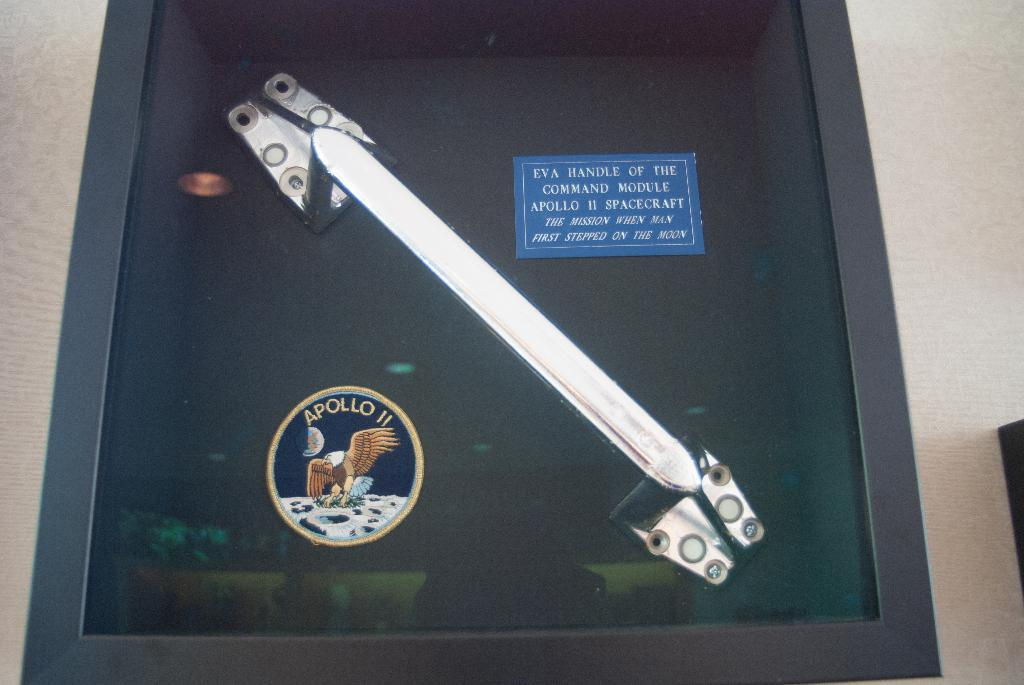What is the color of the box that contains an object in the image? The box is black. What type of decorative items can be seen in the image? There are stickers in the image. What type of background is visible in the image? There is a wall in the image. What type of material is present in the image? There is glass in the image. How many clover leaves can be seen growing on the wall in the image? There are no clover leaves visible on the wall in the image. 